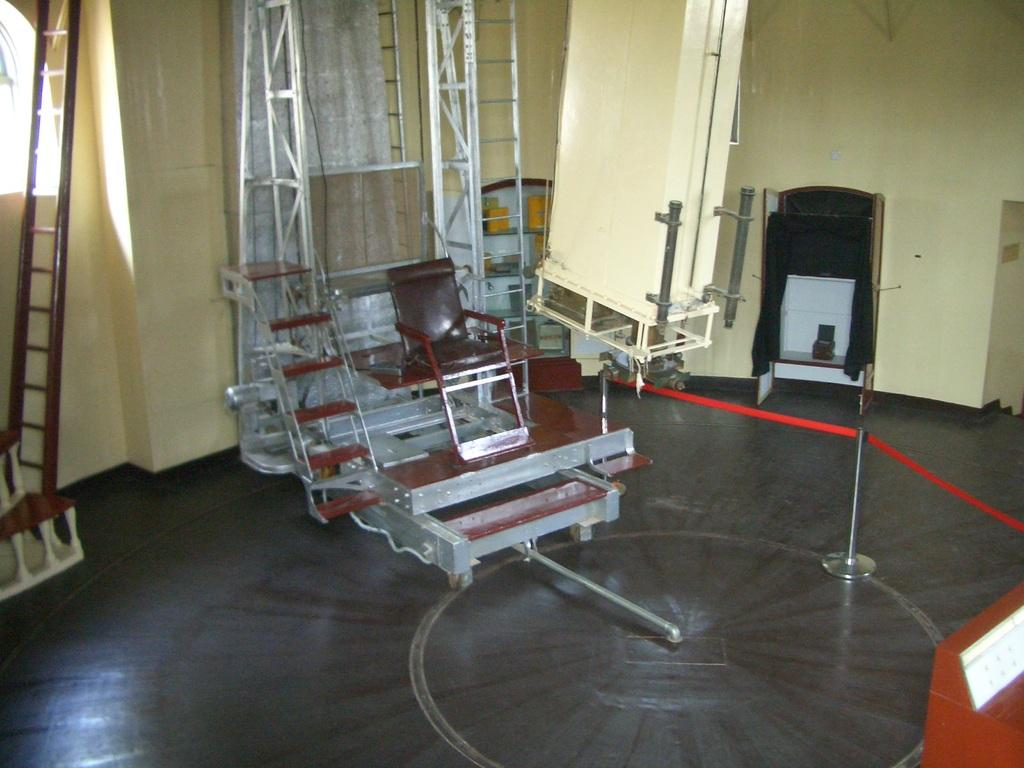What is the color of the equipment in the image? The equipment in the image is brown-colored. What type of objects can be seen in the image that are used for climbing or reaching higher places? There are ladders and poles in the image. What color are the things attached to the poles? The things attached to the poles are red-colored. How does the process of digestion occur in the image? There is no mention of digestion or any living organisms in the image, so it cannot be determined from the image. 